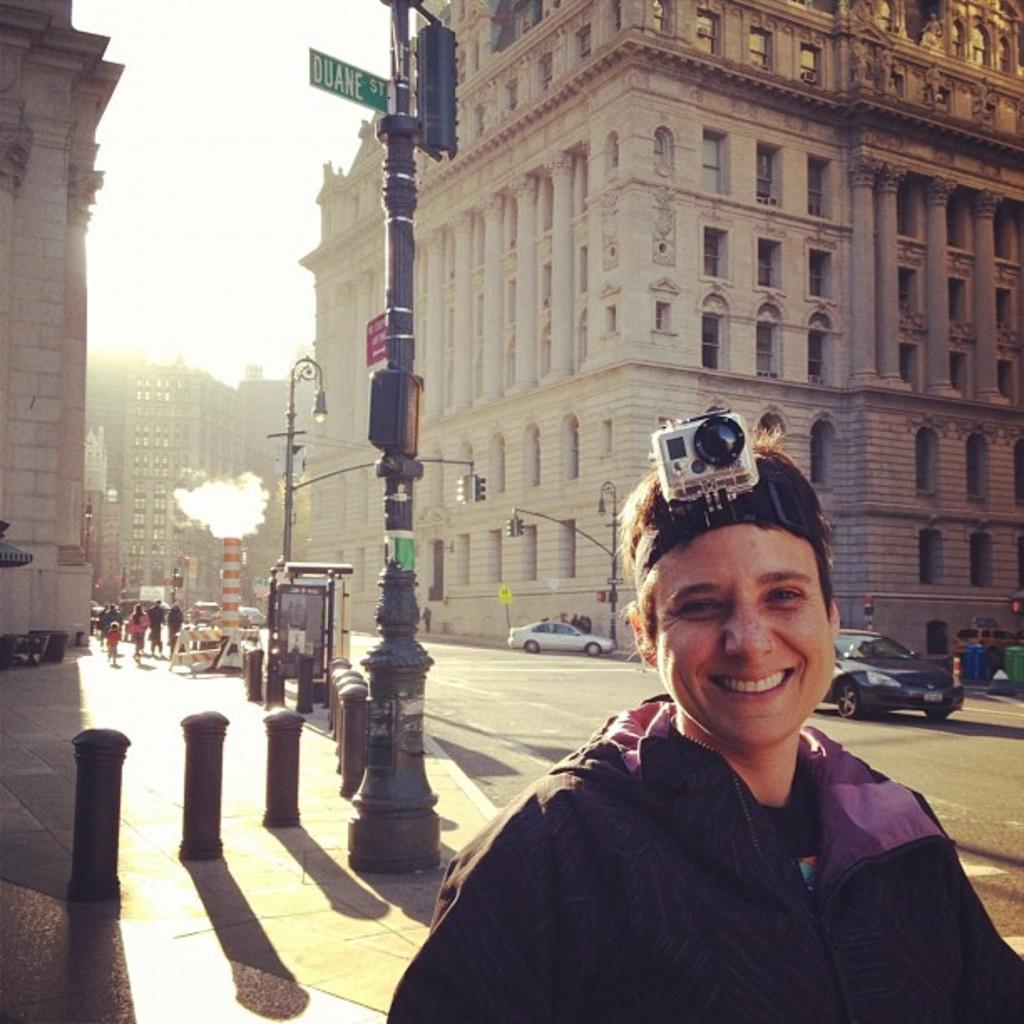What type of structures can be seen in the image? There are buildings in the image. What is happening on the road in the image? Motor vehicles are present on the road in the image. What are the barrier poles used for in the image? Barrier poles are visible in the image, likely to separate traffic or protect pedestrians. What are the street poles used for in the image? Street poles are present in the image, likely to hold street lights or sign boards. What is the purpose of the street lights in the image? Street lights are visible in the image, providing illumination for the area. What information can be found on the sign boards in the image? Sign boards are present in the image, displaying information or directions. What is the chimney associated with in the image? A chimney is visible in the image, likely associated with a building or structure. What can be seen in the sky in the image? The sky is visible in the image. What type of faucet is visible in the image? There is no faucet present in the image. Can you describe the smile on the building in the image? Buildings do not have facial expressions, so there is no smile on the building in the image. 